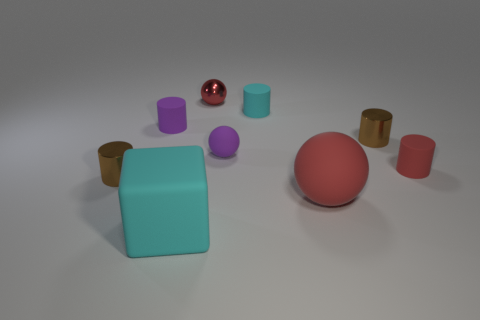What textures appear in the objects displayed? Each object in the image seems to have a smooth surface texture, indicative of materials like plastic or rubber, which gives them a sleek and polished appearance. 